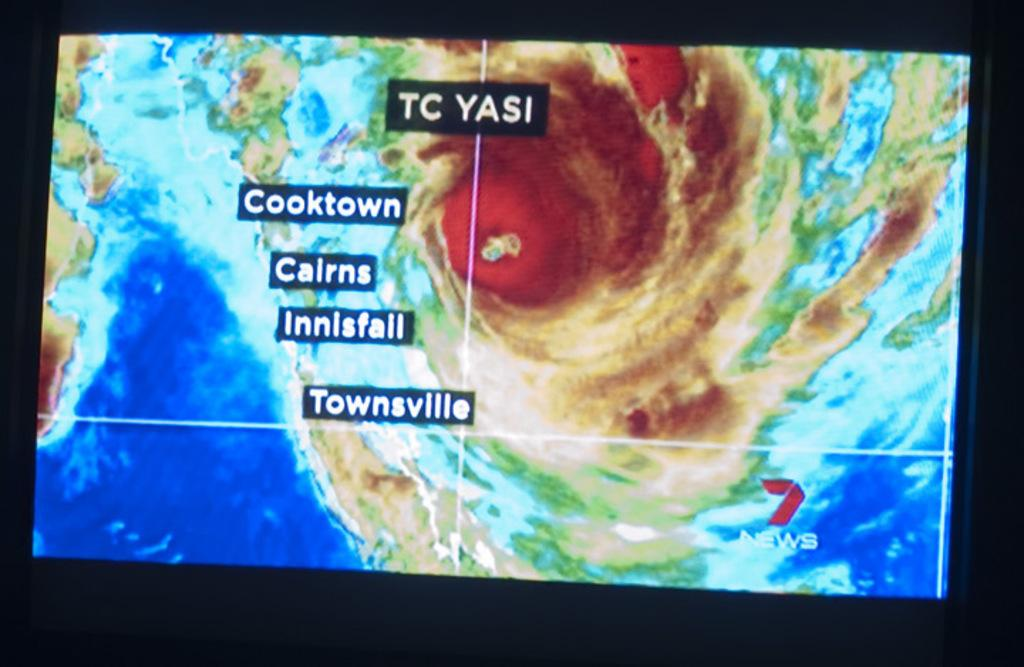Provide a one-sentence caption for the provided image. a weather scan of someplace in TC Yasi, Cooktown and Cairns included. 